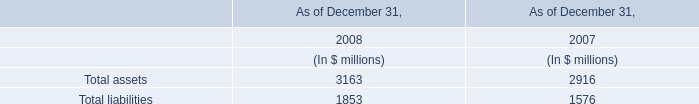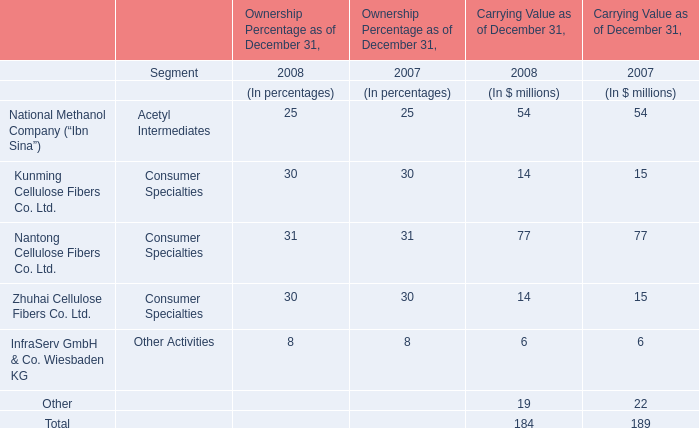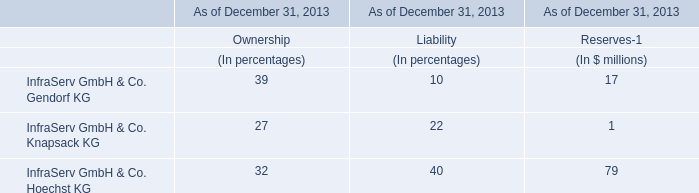What will Total for Carrying Value as of December 31 reach in 2009 if it continues to grow at its current rate? (in dollars in millions) 
Computations: (184 * (1 + ((184 - 189) / 189)))
Answer: 179.13228. 